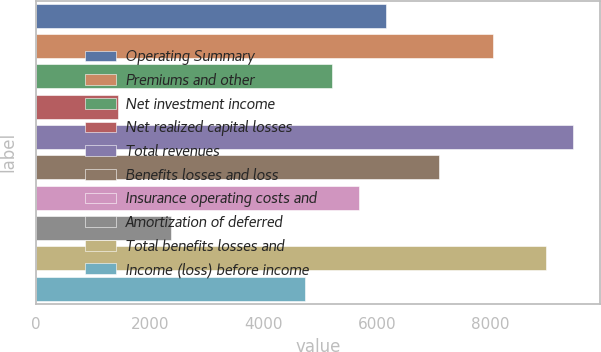Convert chart. <chart><loc_0><loc_0><loc_500><loc_500><bar_chart><fcel>Operating Summary<fcel>Premiums and other<fcel>Net investment income<fcel>Net realized capital losses<fcel>Total revenues<fcel>Benefits losses and loss<fcel>Insurance operating costs and<fcel>Amortization of deferred<fcel>Total benefits losses and<fcel>Income (loss) before income<nl><fcel>6149.9<fcel>8035.1<fcel>5207.3<fcel>1436.9<fcel>9449<fcel>7092.5<fcel>5678.6<fcel>2379.5<fcel>8977.7<fcel>4736<nl></chart> 